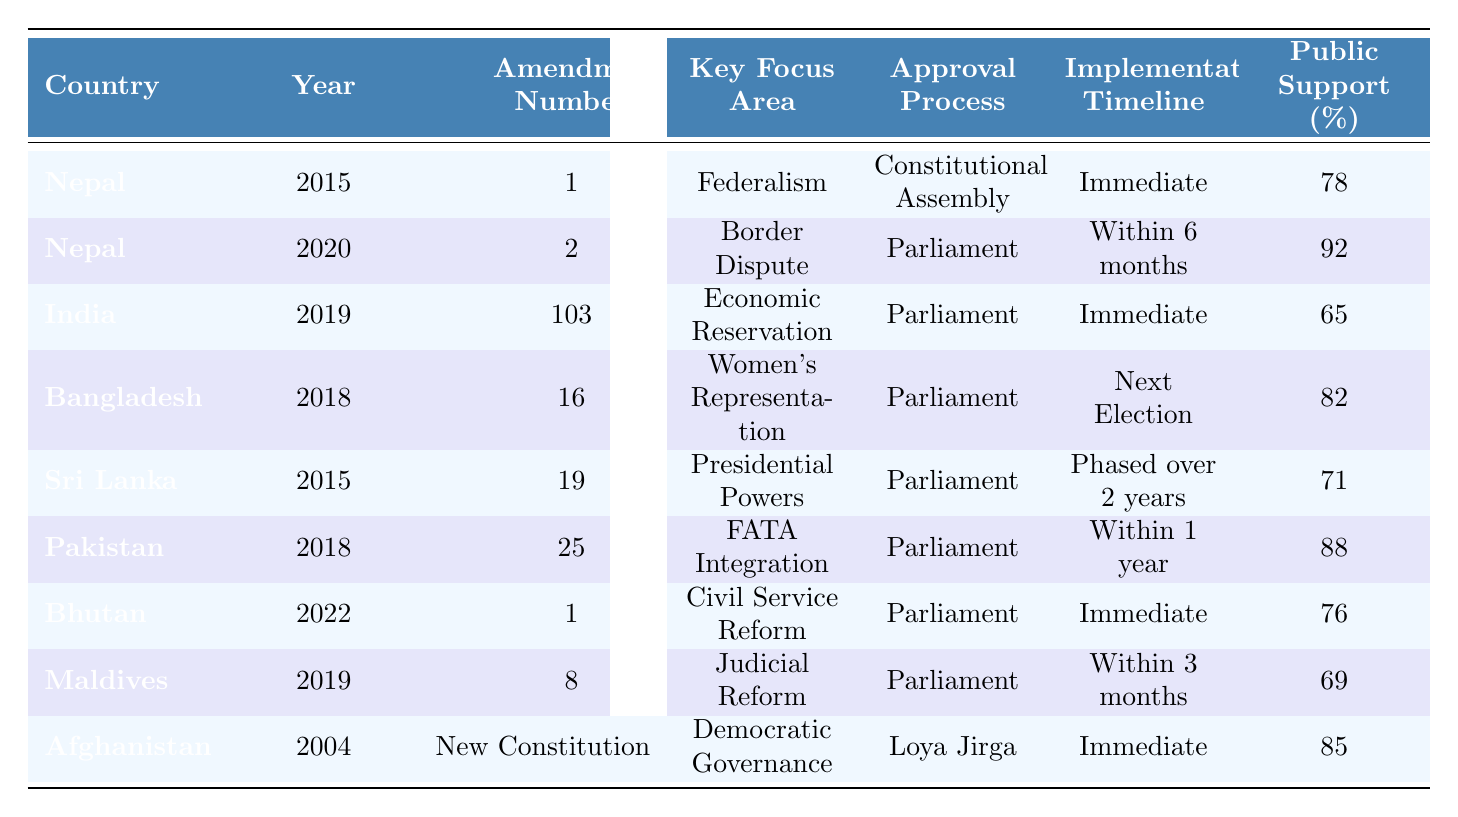What is the public support percentage for the amendment related to border dispute in Nepal? The border dispute amendment in Nepal was passed in 2020, and from the table, its public support percentage is listed as 92%.
Answer: 92% Which country had the lowest public support and what was the percentage? Looking across all the listed countries, India had the lowest public support percentage at 65%.
Answer: 65% How many constitutional amendments were related to immediate implementation? The countries with immediate implementation mentioned in the table are Nepal (2015), India (2019), Bhutan (2022), and Afghanistan (2004), totaling four amendments.
Answer: 4 Is there any amendment in Bangladesh aiming at women's representation? Yes, the amendment in Bangladesh focuses on women's representation and was passed in 2018.
Answer: Yes What is the difference in public support between the amendment in Pakistan and that in Sri Lanka? The public support in Pakistan was 88%, while in Sri Lanka it was 71%. The difference is calculated as 88% - 71% = 17%.
Answer: 17% Which country implemented a constitutional amendment through a Loya Jirga and what was its focus area? Afghanistan implemented a constitutional amendment through a Loya Jirga, which focused on democratic governance.
Answer: Afghanistan; Democratic Governance What is the average public support percentage for the amendments from Nepal and Pakistan? The public support percentages for Nepal’s amendments are 78% and 92%, and for Pakistan it is 88%. The average is calculated as (78 + 92 + 88) / 3 = 86%.
Answer: 86% Which countries had their amendments focused on representation and what was the public support for those amendments? Bangladesh focused on women's representation with a public support of 82%, while India's economic reservation amendment had a support of 65%—both can be classified as representation-related.
Answer: Bangladesh: 82%, India: 65% Did any amendments have a phased implementation timeline? If so, which country was it? Yes, the amendment in Sri Lanka specified a phased implementation over 2 years.
Answer: Yes; Sri Lanka Which country had the amendment associated with civil service reform and what was the approval process? Bhutan had the amendment associated with civil service reform and the approval process was through Parliament.
Answer: Bhutan; Parliament 